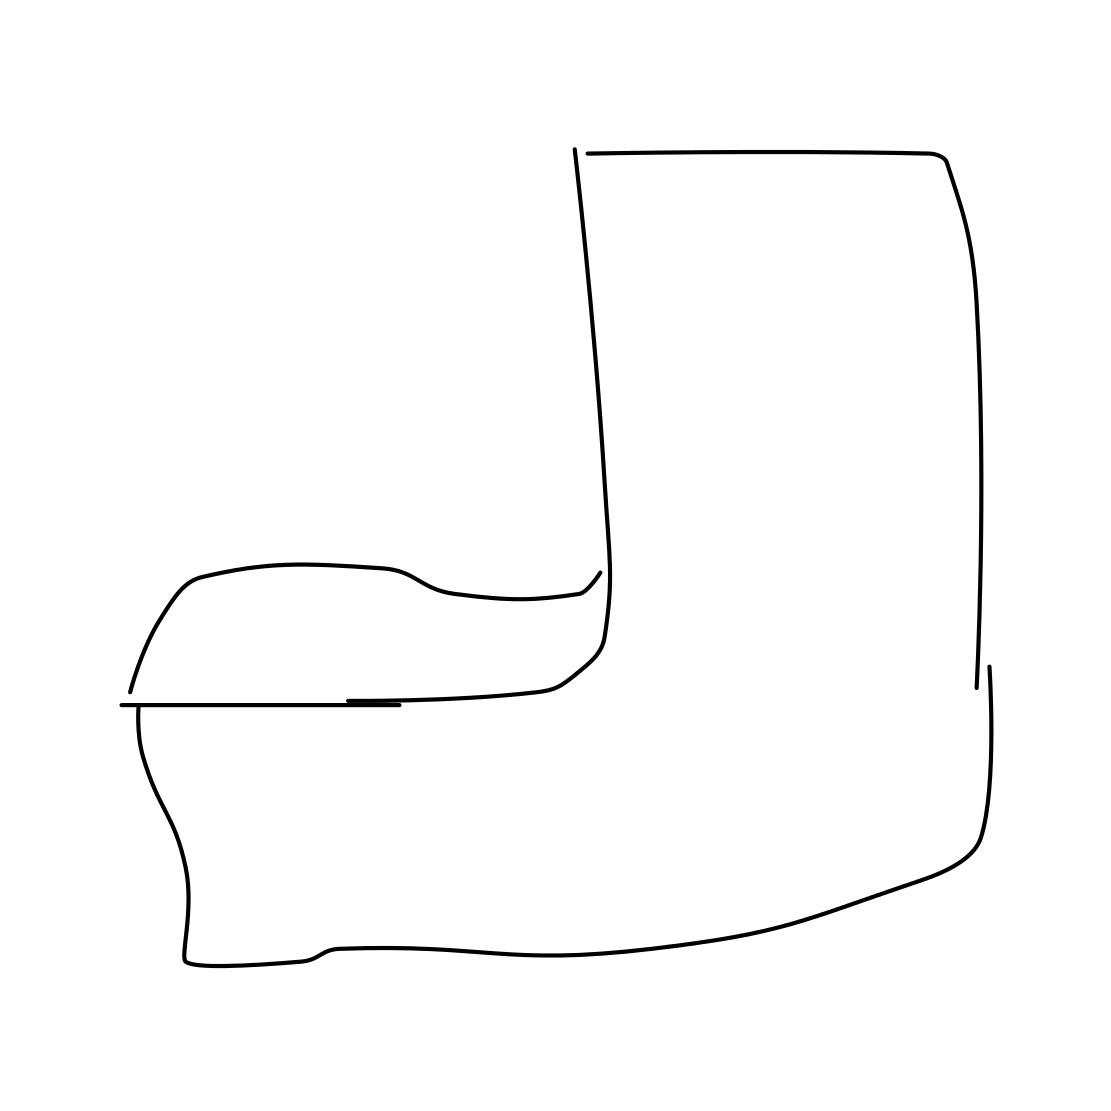Is there a sketchy armchair in the picture? Yes 